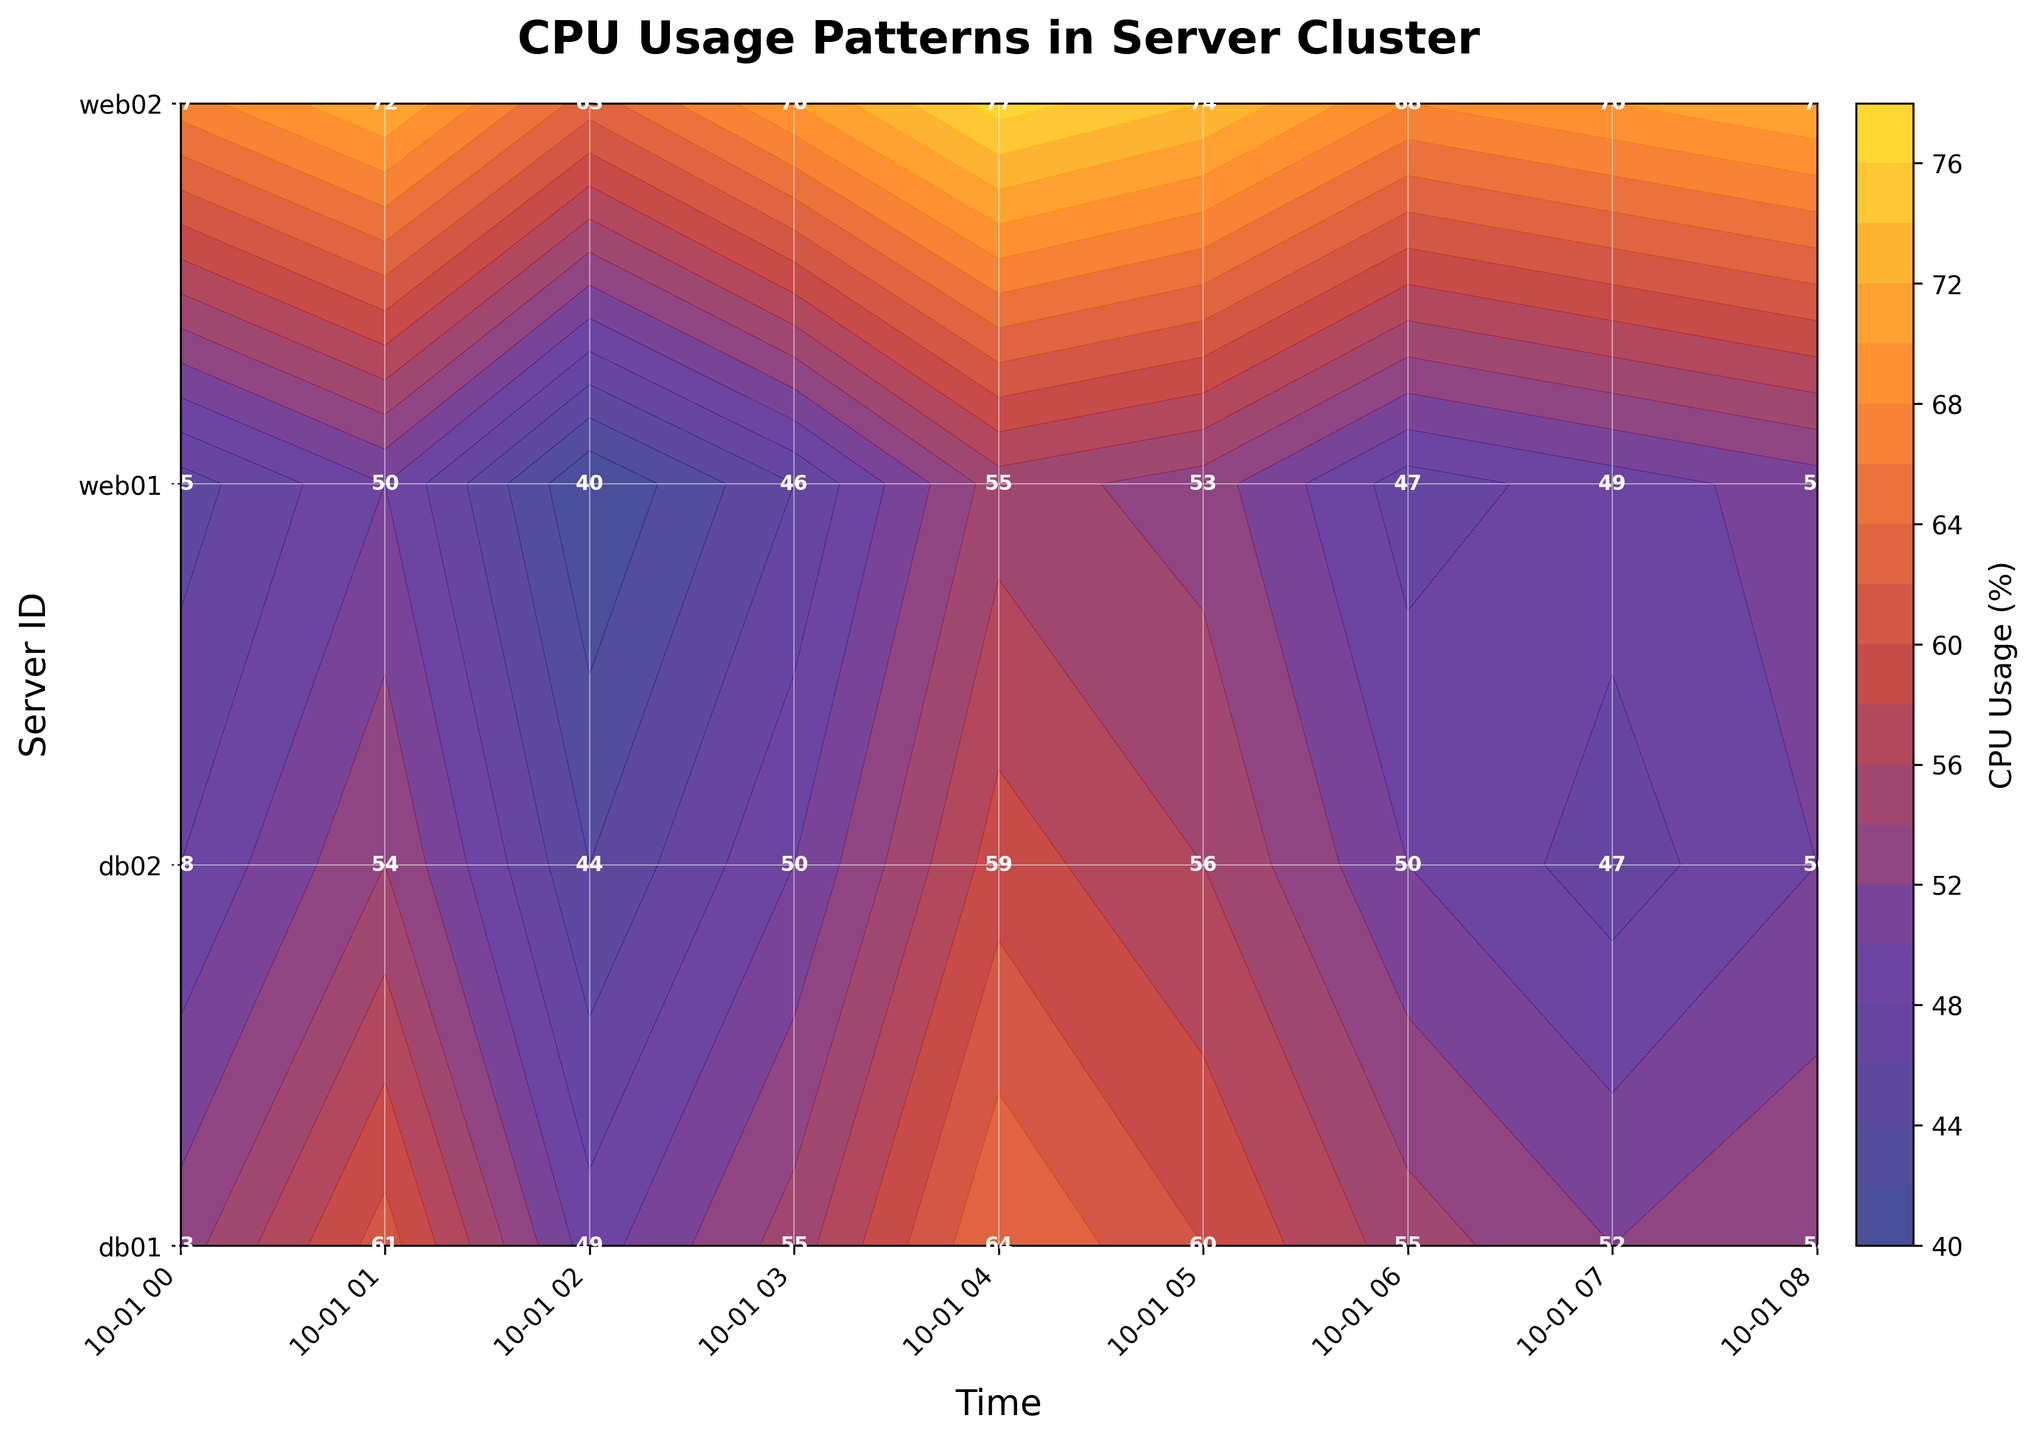What's the title of the plot? The title usually appears at the top of the plot and is clearly labeled to describe the main theme or subject of the visualization. The title of this plot is "CPU Usage Patterns in Server Cluster".
Answer: CPU Usage Patterns in Server Cluster What is the color range used for representing CPU usage? The color range is visible in the contour plot and usually indicated by the color bar, which shows the mapping between colors and values. For this plot, the colors range from dark blue to yellow.
Answer: Dark blue to yellow What are the labels on the x-axis and y-axis? X-axis and y-axis labels are typically shown below and to the left of the plot area respectively. They provide context about the data dimensions. The x-axis label is "Time" and the y-axis label is "Server ID".
Answer: Time and Server ID What time period shows the lowest CPU usage for server web01? By examining the contour plot and focusing on the web01 row, the area with the darkest color represents the lowest CPU usage. The time period is found between "2023-10-01 02:00:00", where the usage is lowest.
Answer: 2023-10-01 02:00:00 Compare the CPU usage between servers web02 and db01 at 04:00:00. Which server had higher usage? To compare CPU usage, locate the values for both servers at the given time. At 04:00:00, web02 has a usage of 77% and db01 has a usage of 64%, so web02 had higher usage.
Answer: web02 Which server had the most varied CPU usage over time? To determine variability, observe changes in CPU usage over time for each server by looking at the color gradient transitions within their rows. The server with the most varying colors (hence highest variability) is web02, which has a wider range of colors compared to the other servers.
Answer: web02 What is the average CPU usage for server db02 throughout the given time period? We need to sum the CPU usage values for db02 across all timestamps and divide by the number of data points. Values: (48 + 54 + 44 + 50 + 59 + 56 + 50 + 47) = 408. There are 8 timestamps, so the average is 408/8.
Answer: 51% Which time period had the highest CPU usage for all servers combined? Sum the CPU usage for all servers at each timestamp, then identify which sum is the highest. The sums are: (213, 237, 196, 221, 255, 243, 220, 227). The highest sum is at 2023-10-01 04:00:00.
Answer: 2023-10-01 04:00:00 What pattern can be observed in the CPU usage of web01? Look for trends in the web01 data across time. Web01 shows fluctuating CPU usage with peaks around 04:00:00 and troughs at 02:00:00, indicating cyclical usage.
Answer: Fluctuating with peaks at 04:00:00 and troughs at 02:00:00 